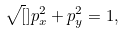<formula> <loc_0><loc_0><loc_500><loc_500>\sqrt { [ } ] { p _ { x } ^ { 2 } + p _ { y } ^ { 2 } = 1 } ,</formula> 